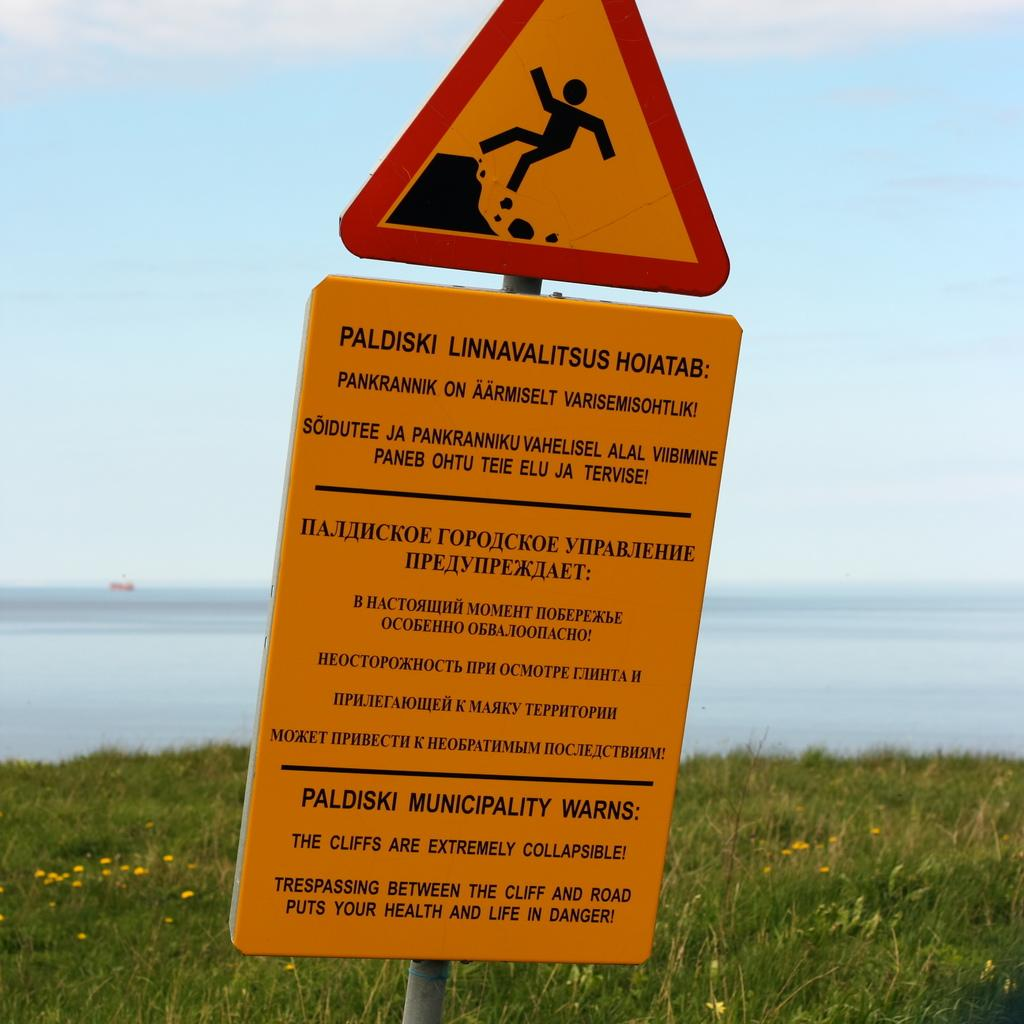<image>
Create a compact narrative representing the image presented. A warning sign from Paldiski Municipality warns about cliffs collapsing in three languages. 